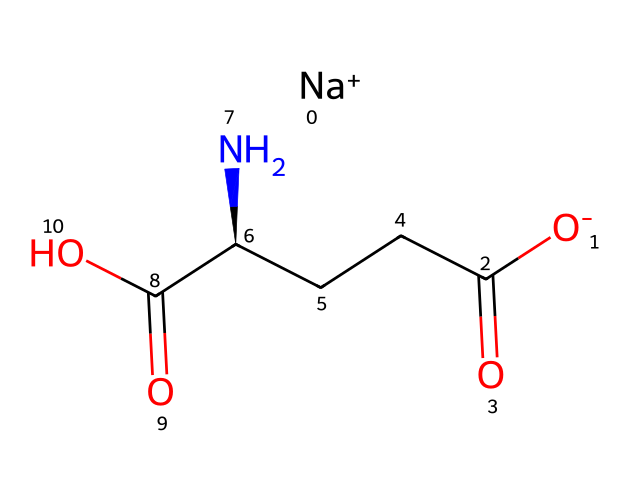What is the molecular formula of monosodium glutamate? Analyzing the SMILES representation, we can count the number of each type of atom present. In this case, the molecular formula can be derived as C5H8N1Na1O4.
Answer: C5H8N1Na1O4 How many carbon atoms are in the structure? By breaking down the structure represented in the SMILES, we observe carbon atoms in various functional groups and at least five carbon atoms present in the chain and groups.
Answer: 5 What functional groups are present in MSG? The structure consists of a carboxylic acid group (-COOH) and an amine group (-NH2), as seen in the side chains of the molecule. Both of these contribute significantly to its function.
Answer: carboxylic acid, amine How does the presence of sodium affect MSG's solubility? Sodium acts as a counterion in this structure, typically increasing the solubility of the compound in water due to its ionic nature, allowing the molecule to dissociate into its components.
Answer: increases What role does the amine group play in MSG's flavor enhancement? The amine group (-NH2) contributes to the umami flavor characteristic of monosodium glutamate, which enhances the taste profile of foods by modifying taste perception.
Answer: flavor enhancement What is the charge on the sodium in MSG? From the SMILES representation, we can see the sodium is indicated as a positively charged ion, denoted by "[Na+]".
Answer: +1 